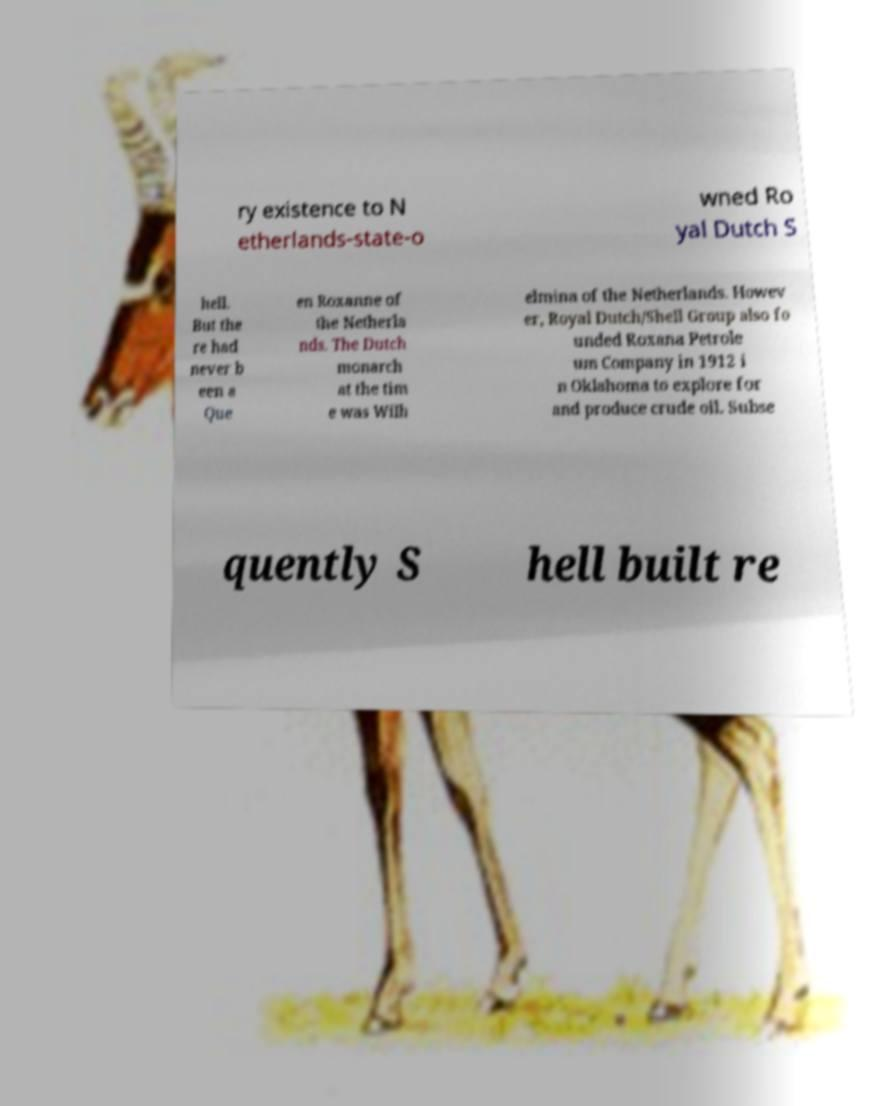Please read and relay the text visible in this image. What does it say? ry existence to N etherlands-state-o wned Ro yal Dutch S hell. But the re had never b een a Que en Roxanne of the Netherla nds. The Dutch monarch at the tim e was Wilh elmina of the Netherlands. Howev er, Royal Dutch/Shell Group also fo unded Roxana Petrole um Company in 1912 i n Oklahoma to explore for and produce crude oil. Subse quently S hell built re 